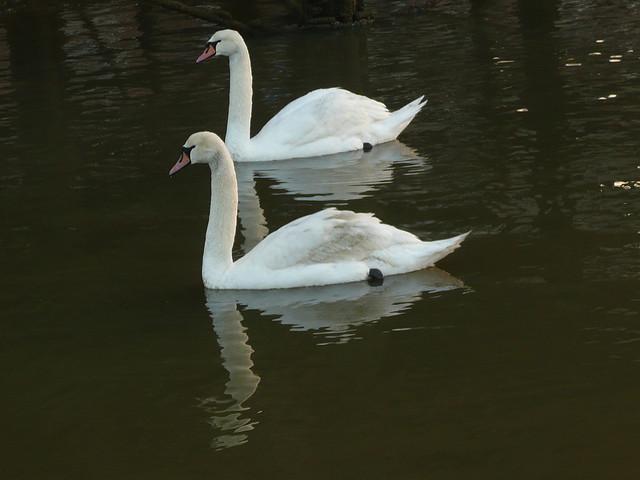How many animals are pictured?
Be succinct. 2. How many vehicles are in the photo?
Keep it brief. 0. What type of birds are these?
Short answer required. Swan. Are these birds mated?
Write a very short answer. No. Does this bird eat fish?
Short answer required. Yes. What is in the water?
Short answer required. Swans. What is there a reflection of in the water?
Be succinct. Yes. 